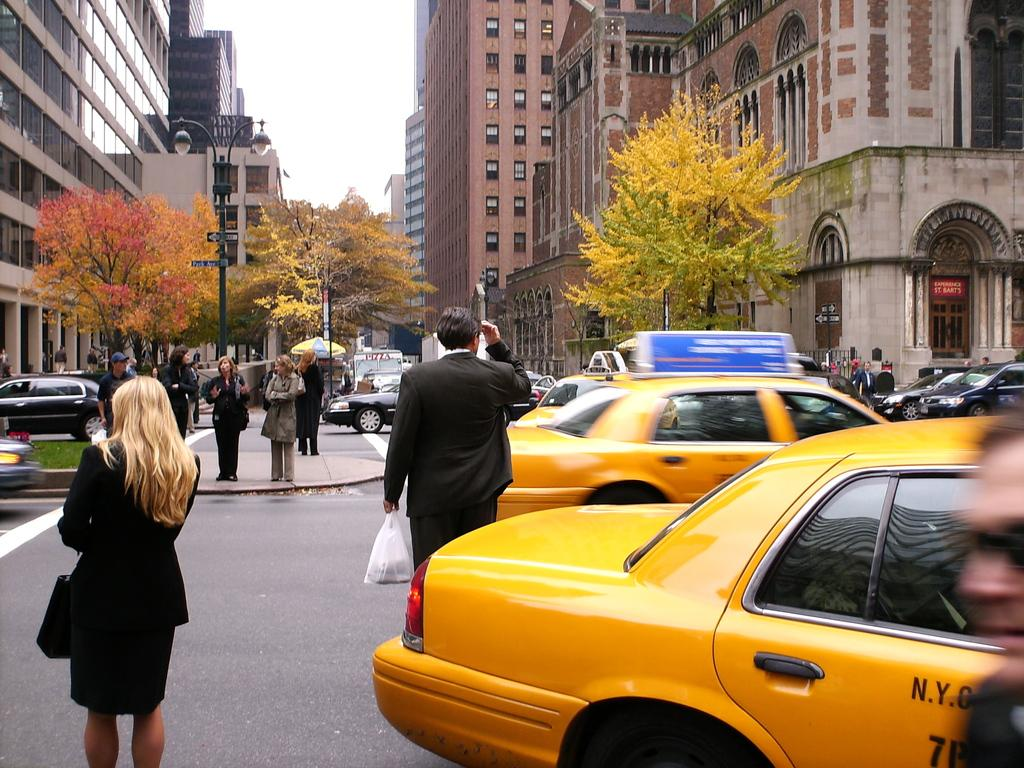<image>
Present a compact description of the photo's key features. A busy street with pedestrians and tow taxi's that say N.Y.C. 